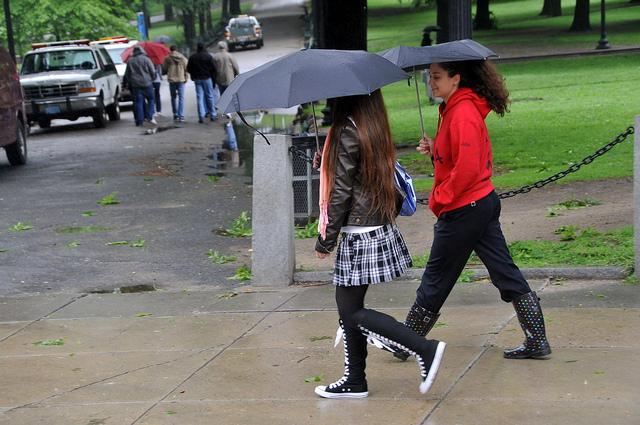Is this a tourist attraction?
Be succinct. No. How many tracks are at the intersection?
Keep it brief. 0. What color is the child's umbrella?
Keep it brief. Black. What color is the girls umbrella?
Quick response, please. Black. How many people are in this image?
Short answer required. 7. Are these two women's umbrellas the same color?
Short answer required. Yes. What color is the lady wearing?
Concise answer only. Red. What to the white lines depict?
Keep it brief. Shoelaces. Is the umbrella open?
Quick response, please. Yes. Is this photo taken in the city?
Be succinct. Yes. What type of shoes is the woman wearing?
Concise answer only. Boots. What color laces is on the girl's boots?
Concise answer only. White. What pattern is the skirt?
Keep it brief. Plaid. Is it sunny?
Concise answer only. No. What color is the woman's pants?
Concise answer only. Black. Where are these people walking too?
Short answer required. School. 